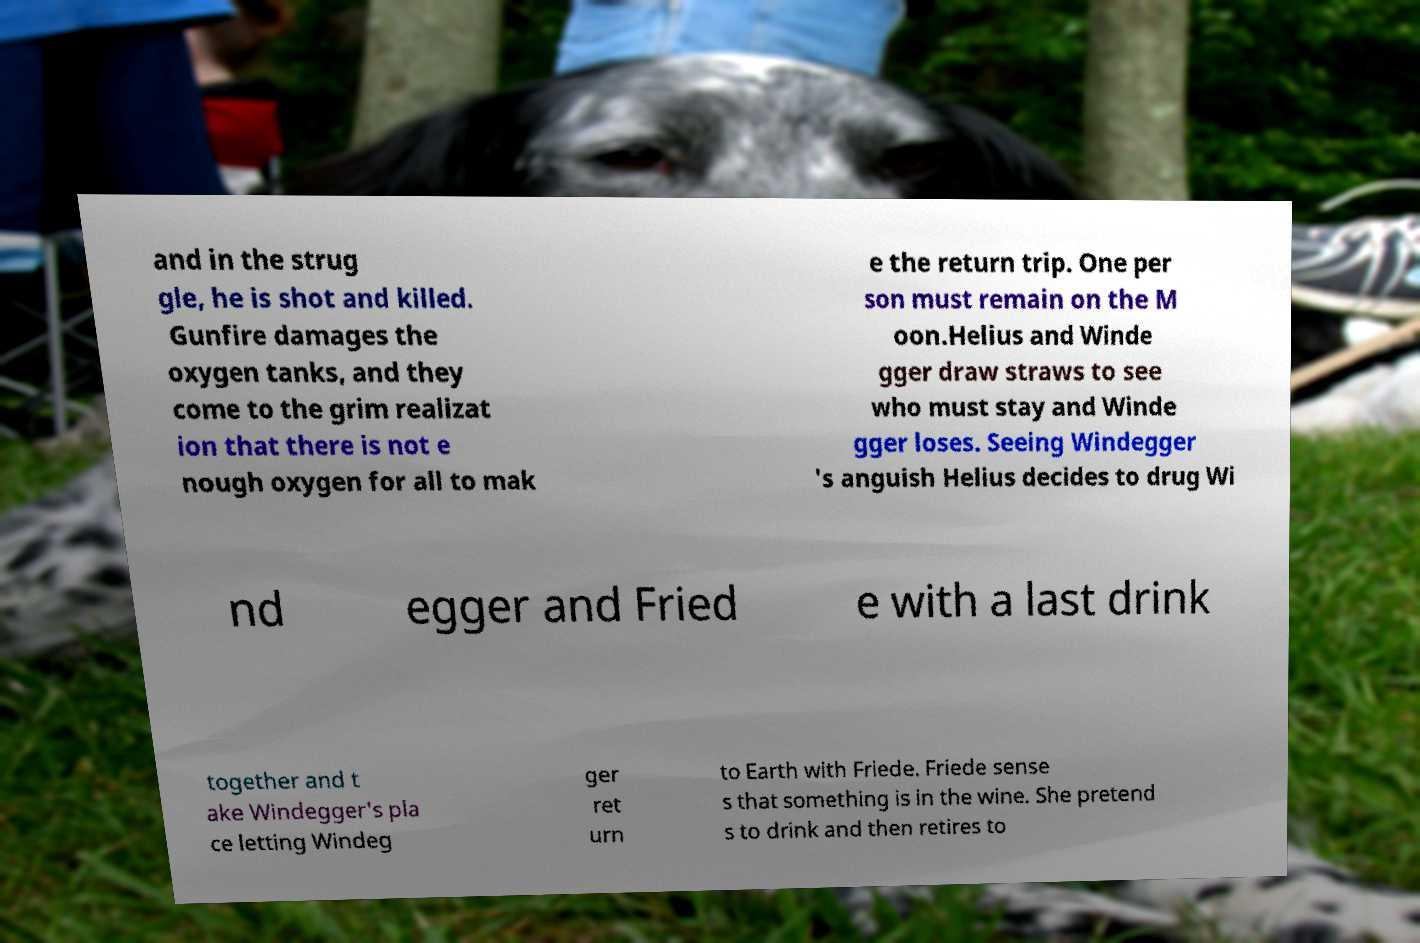For documentation purposes, I need the text within this image transcribed. Could you provide that? and in the strug gle, he is shot and killed. Gunfire damages the oxygen tanks, and they come to the grim realizat ion that there is not e nough oxygen for all to mak e the return trip. One per son must remain on the M oon.Helius and Winde gger draw straws to see who must stay and Winde gger loses. Seeing Windegger 's anguish Helius decides to drug Wi nd egger and Fried e with a last drink together and t ake Windegger's pla ce letting Windeg ger ret urn to Earth with Friede. Friede sense s that something is in the wine. She pretend s to drink and then retires to 